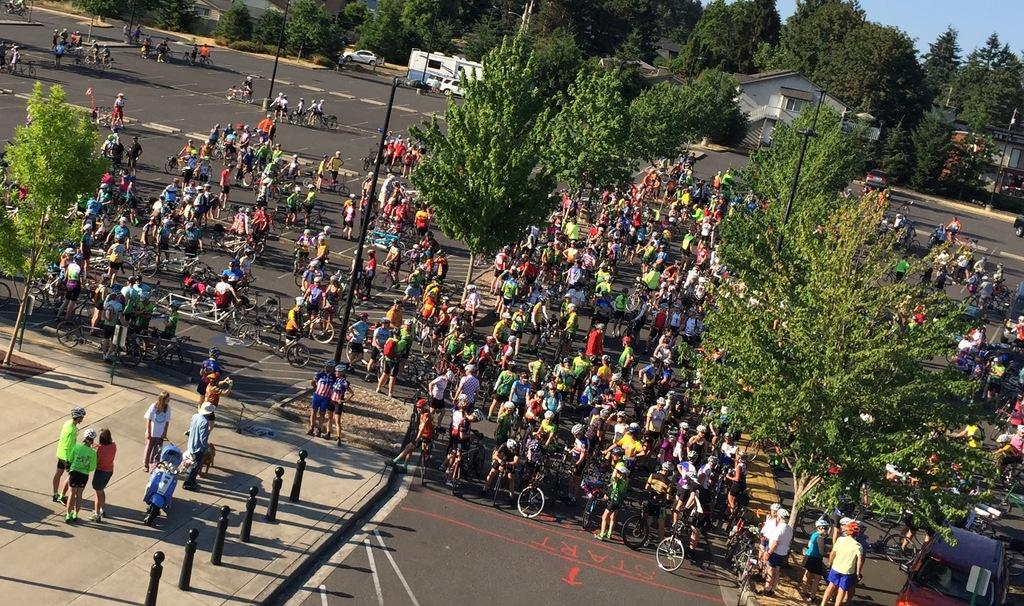Who or what can be seen in the image? There are people in the image. What type of natural elements are present in the image? There are trees in the image. What man-made structures can be seen in the image? There are poles, houses, and vehicles in the image. Are there any transportation-related items in the image? Yes, there are bicycles in the image. What can be seen beneath the people and objects in the image? The ground is visible in the image. What is visible above the people and objects in the image? The sky is visible in the image. What type of produce is being harvested in the image? There is no produce or harvesting activity depicted in the image. What event is taking place in the image? There is no specific event taking place in the image; it simply shows people, trees, poles, houses, vehicles, bicycles, ground, and sky. 